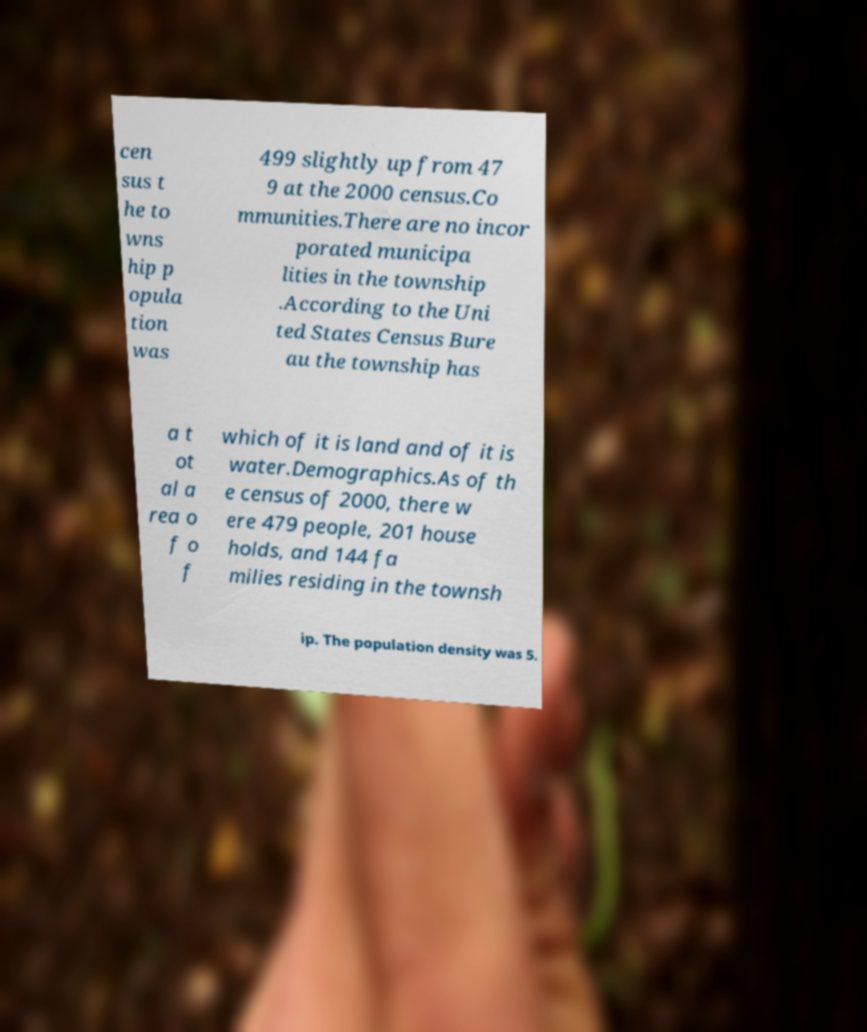Can you read and provide the text displayed in the image?This photo seems to have some interesting text. Can you extract and type it out for me? cen sus t he to wns hip p opula tion was 499 slightly up from 47 9 at the 2000 census.Co mmunities.There are no incor porated municipa lities in the township .According to the Uni ted States Census Bure au the township has a t ot al a rea o f o f which of it is land and of it is water.Demographics.As of th e census of 2000, there w ere 479 people, 201 house holds, and 144 fa milies residing in the townsh ip. The population density was 5. 